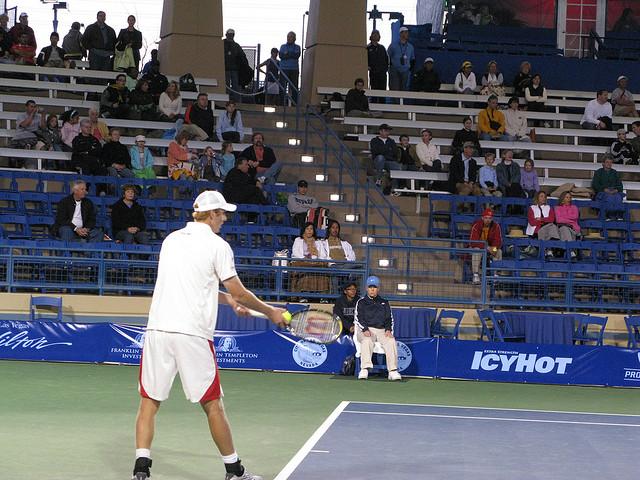Are there lots of people in the stadium?
Give a very brief answer. No. Is there a full crowd?
Keep it brief. No. What is this person doing?
Quick response, please. Playing tennis. Are those his family watching him?
Concise answer only. No. 